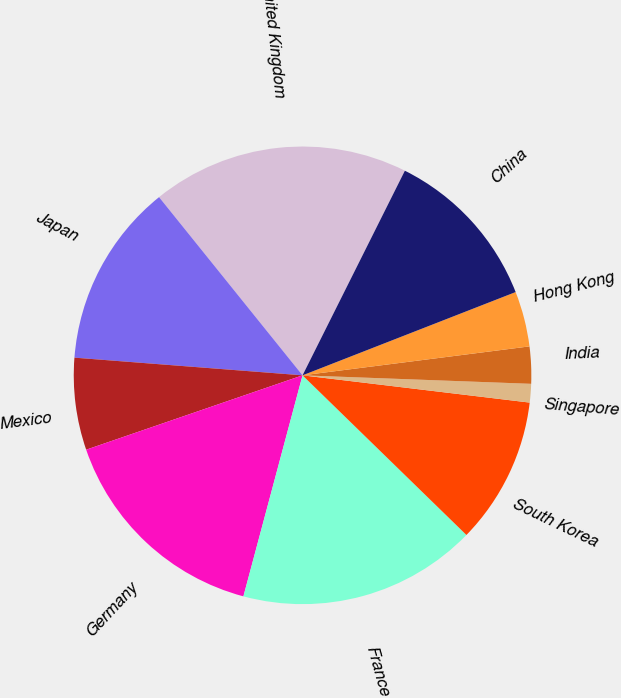Convert chart to OTSL. <chart><loc_0><loc_0><loc_500><loc_500><pie_chart><fcel>United Kingdom<fcel>Japan<fcel>Mexico<fcel>Germany<fcel>France<fcel>South Korea<fcel>Singapore<fcel>India<fcel>Hong Kong<fcel>China<nl><fcel>18.17%<fcel>12.98%<fcel>6.5%<fcel>15.57%<fcel>16.87%<fcel>10.39%<fcel>1.31%<fcel>2.61%<fcel>3.91%<fcel>11.69%<nl></chart> 